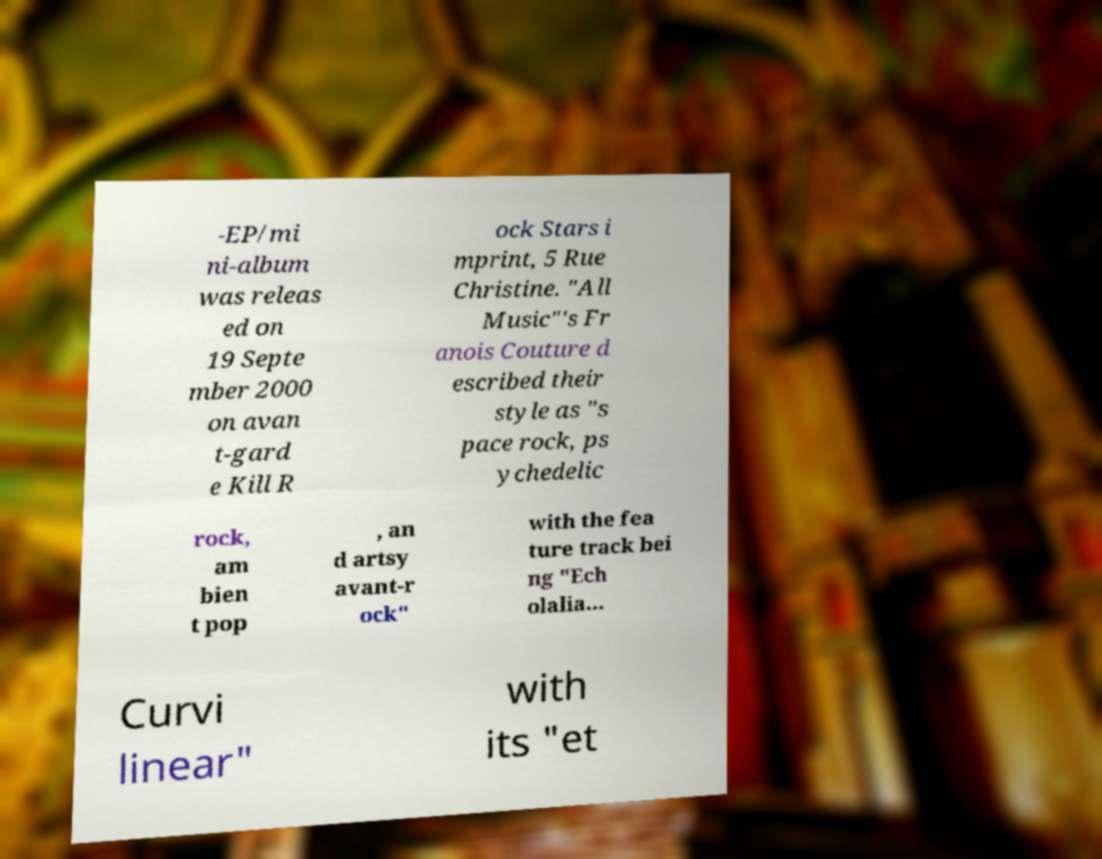Please identify and transcribe the text found in this image. -EP/mi ni-album was releas ed on 19 Septe mber 2000 on avan t-gard e Kill R ock Stars i mprint, 5 Rue Christine. "All Music"'s Fr anois Couture d escribed their style as "s pace rock, ps ychedelic rock, am bien t pop , an d artsy avant-r ock" with the fea ture track bei ng "Ech olalia... Curvi linear" with its "et 